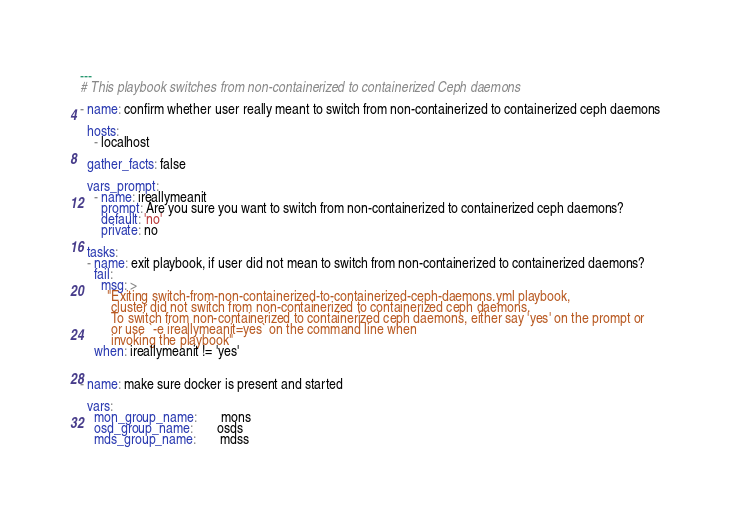<code> <loc_0><loc_0><loc_500><loc_500><_YAML_>---
# This playbook switches from non-containerized to containerized Ceph daemons

- name: confirm whether user really meant to switch from non-containerized to containerized ceph daemons

  hosts:
    - localhost

  gather_facts: false

  vars_prompt:
    - name: ireallymeanit
      prompt: Are you sure you want to switch from non-containerized to containerized ceph daemons?
      default: 'no'
      private: no

  tasks:
  - name: exit playbook, if user did not mean to switch from non-containerized to containerized daemons?
    fail:
      msg: >
        "Exiting switch-from-non-containerized-to-containerized-ceph-daemons.yml playbook,
         cluster did not switch from non-containerized to containerized ceph daemons.
         To switch from non-containerized to containerized ceph daemons, either say 'yes' on the prompt or
         or use `-e ireallymeanit=yes` on the command line when
         invoking the playbook"
    when: ireallymeanit != 'yes'


- name: make sure docker is present and started

  vars:
    mon_group_name:       mons
    osd_group_name:       osds
    mds_group_name:       mdss</code> 